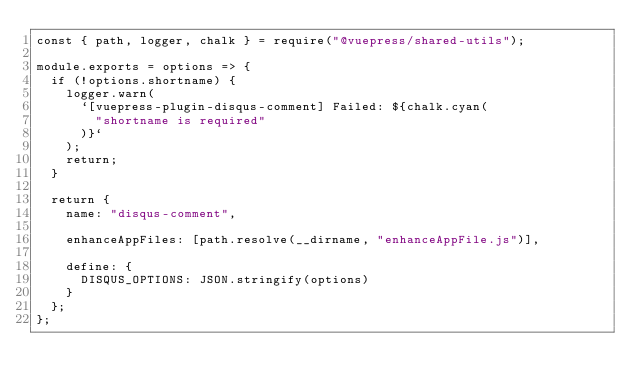<code> <loc_0><loc_0><loc_500><loc_500><_JavaScript_>const { path, logger, chalk } = require("@vuepress/shared-utils");

module.exports = options => {
  if (!options.shortname) {
    logger.warn(
      `[vuepress-plugin-disqus-comment] Failed: ${chalk.cyan(
        "shortname is required"
      )}`
    );
    return;
  }

  return {
    name: "disqus-comment",

    enhanceAppFiles: [path.resolve(__dirname, "enhanceAppFile.js")],

    define: {
      DISQUS_OPTIONS: JSON.stringify(options)
    }
  };
};
</code> 